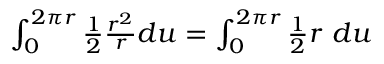<formula> <loc_0><loc_0><loc_500><loc_500>\begin{array} { r } { \int _ { 0 } ^ { 2 \pi r } { \frac { 1 } { 2 } } { \frac { r ^ { 2 } } { r } } d u = \int _ { 0 } ^ { 2 \pi r } { \frac { 1 } { 2 } } r \ d u } \end{array}</formula> 